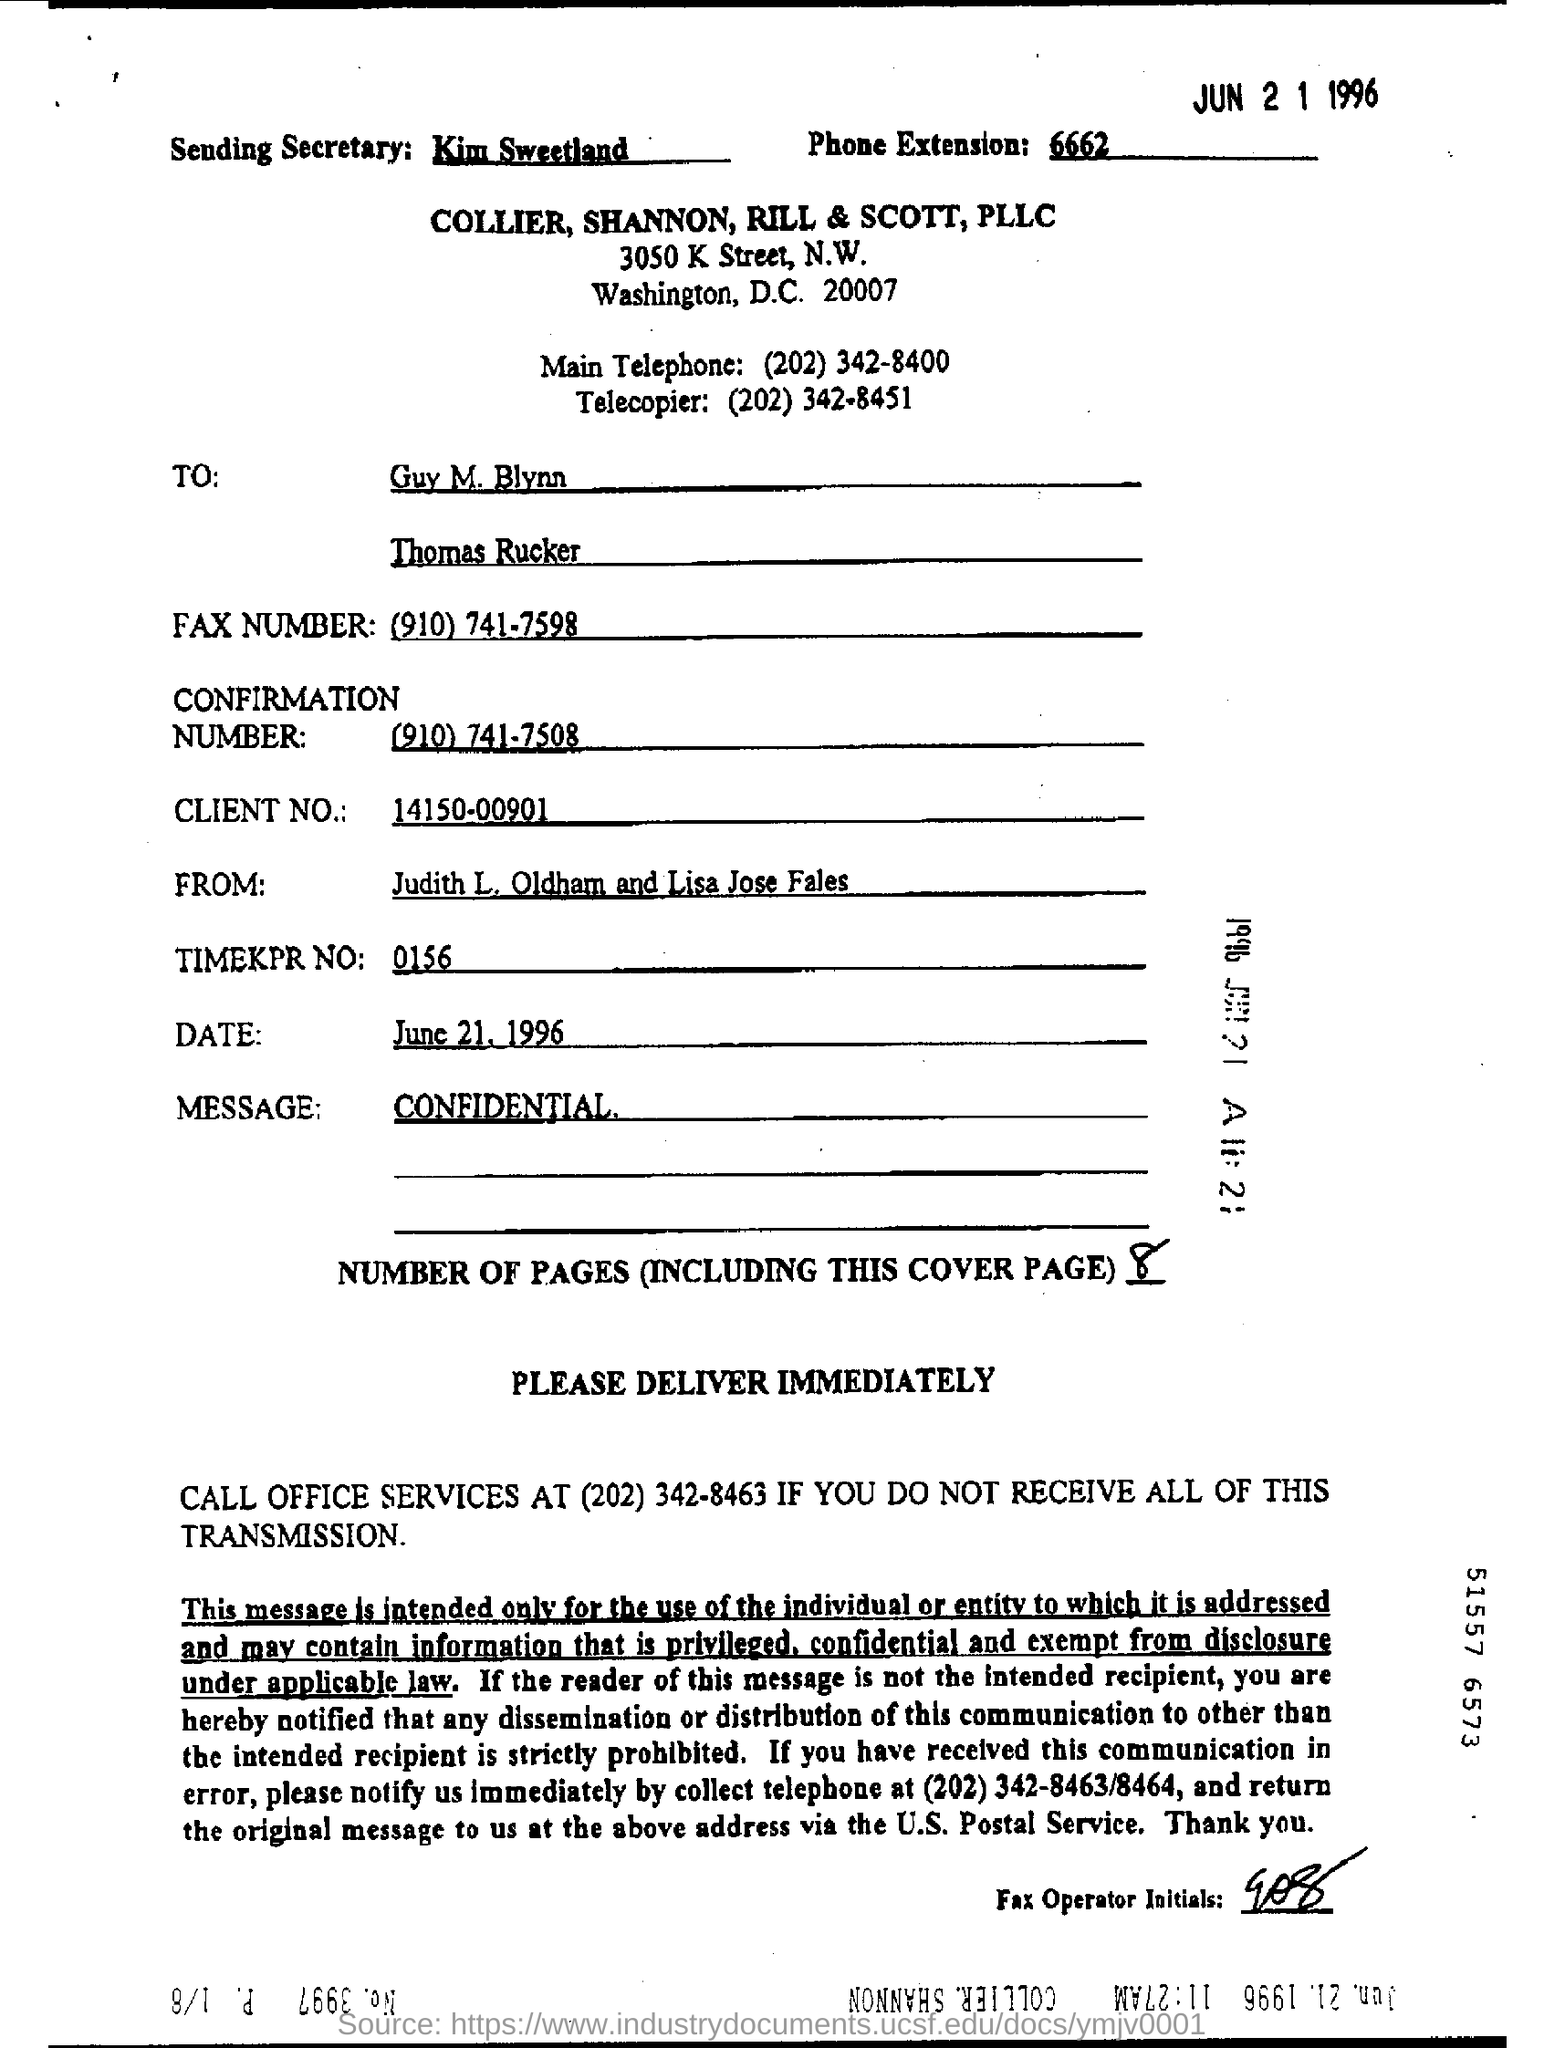Who is the sending secretary?
Ensure brevity in your answer.  Kim Sweetland. What is the client no mentioned in the form?
Keep it short and to the point. 14150-00901. What is the phone extension given in the form?
Make the answer very short. 6662. What is the Fax number?
Provide a short and direct response. (910) 741-7508. What is the confirmation number?
Provide a short and direct response. (910) 741-7508. What is the message?
Provide a short and direct response. Confidential. 